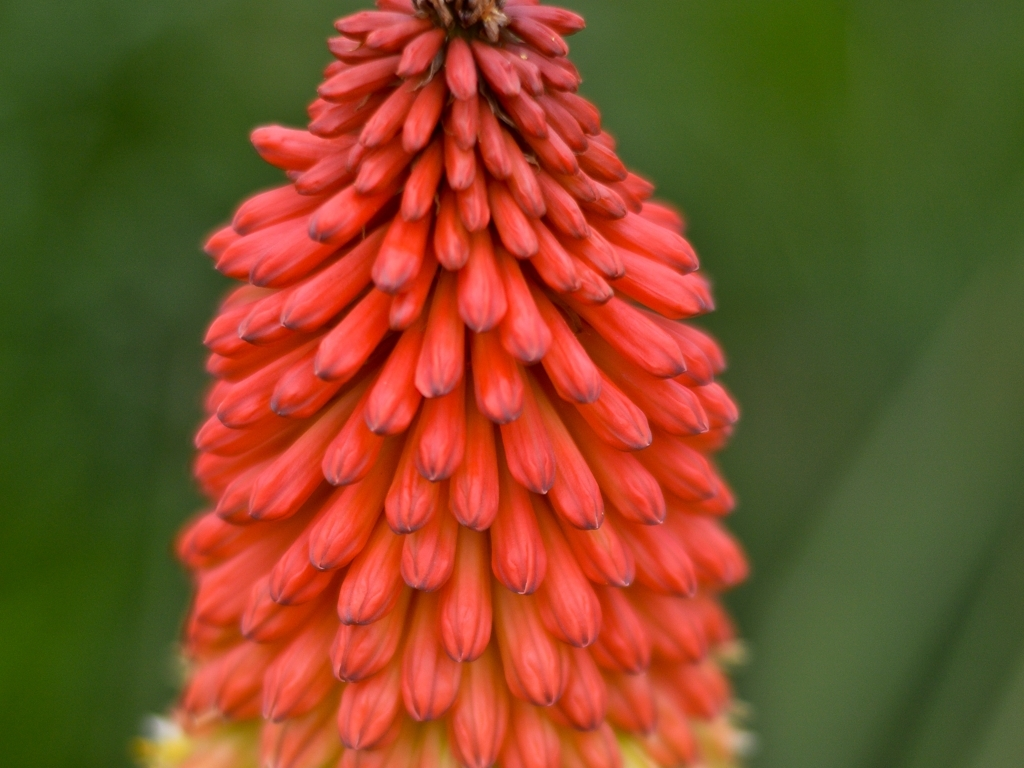What kind of care do these flowers need? They require minimal care, doing well in full sun and withstanding dry conditions once established. It's advisable to water them during prolonged dry spells and to remove spent flower spikes to encourage more blooms. 